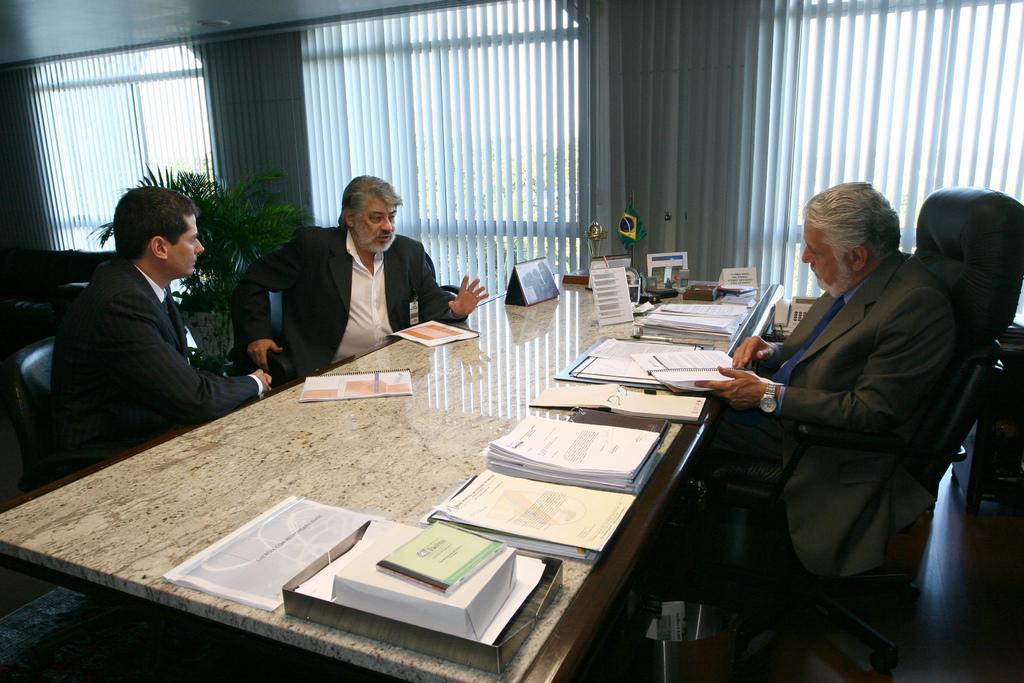How would you summarize this image in a sentence or two? In this image there are three man sitting on a chair there are a few papers on a table,at the back ground there is a plant,a window and a wall. 